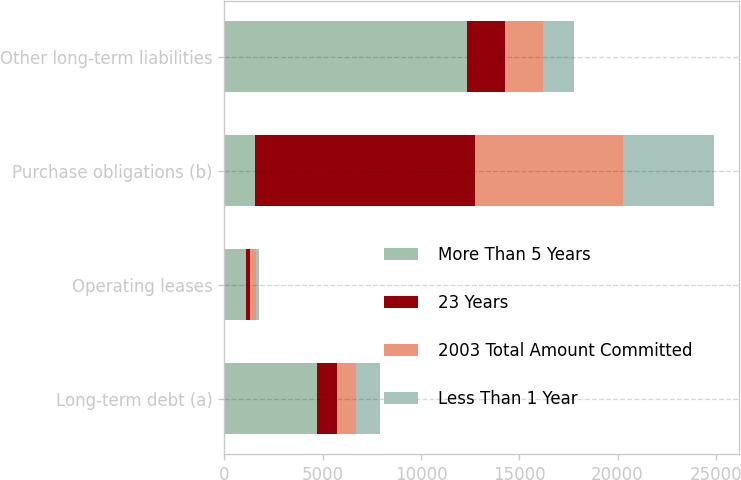Convert chart to OTSL. <chart><loc_0><loc_0><loc_500><loc_500><stacked_bar_chart><ecel><fcel>Long-term debt (a)<fcel>Operating leases<fcel>Purchase obligations (b)<fcel>Other long-term liabilities<nl><fcel>More Than 5 Years<fcel>4700<fcel>1081<fcel>1558<fcel>12337<nl><fcel>23 Years<fcel>1040<fcel>205<fcel>11166<fcel>1930<nl><fcel>2003 Total Amount Committed<fcel>973<fcel>304<fcel>7554<fcel>1963<nl><fcel>Less Than 1 Year<fcel>1213<fcel>167<fcel>4653<fcel>1558<nl></chart> 